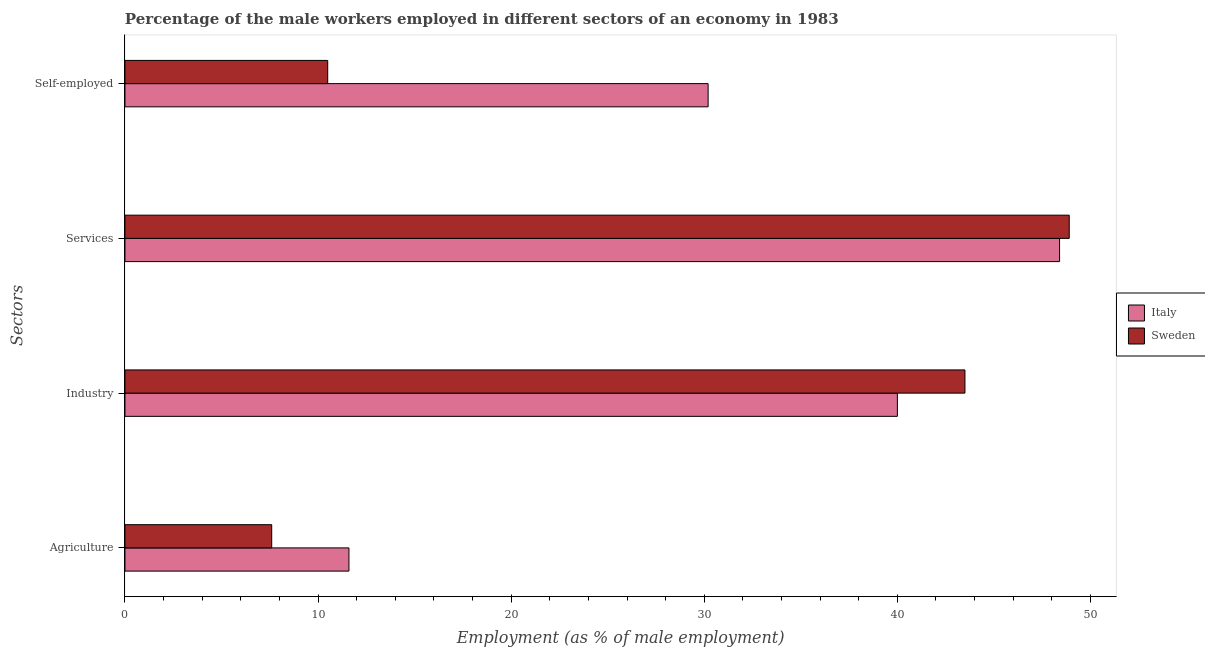How many groups of bars are there?
Offer a very short reply. 4. What is the label of the 3rd group of bars from the top?
Provide a succinct answer. Industry. What is the percentage of self employed male workers in Italy?
Offer a very short reply. 30.2. Across all countries, what is the maximum percentage of male workers in agriculture?
Keep it short and to the point. 11.6. What is the total percentage of male workers in industry in the graph?
Ensure brevity in your answer.  83.5. What is the difference between the percentage of self employed male workers in Italy and that in Sweden?
Ensure brevity in your answer.  19.7. What is the difference between the percentage of male workers in services in Sweden and the percentage of self employed male workers in Italy?
Offer a terse response. 18.7. What is the average percentage of male workers in services per country?
Give a very brief answer. 48.65. What is the difference between the percentage of male workers in agriculture and percentage of male workers in services in Sweden?
Provide a short and direct response. -41.3. What is the ratio of the percentage of male workers in industry in Sweden to that in Italy?
Keep it short and to the point. 1.09. Is the percentage of male workers in agriculture in Italy less than that in Sweden?
Provide a short and direct response. No. Is the difference between the percentage of male workers in industry in Sweden and Italy greater than the difference between the percentage of male workers in agriculture in Sweden and Italy?
Provide a short and direct response. Yes. What is the difference between the highest and the second highest percentage of self employed male workers?
Provide a short and direct response. 19.7. What is the difference between the highest and the lowest percentage of male workers in services?
Make the answer very short. 0.5. Is the sum of the percentage of male workers in agriculture in Italy and Sweden greater than the maximum percentage of self employed male workers across all countries?
Your answer should be very brief. No. Is it the case that in every country, the sum of the percentage of male workers in services and percentage of male workers in agriculture is greater than the sum of percentage of self employed male workers and percentage of male workers in industry?
Your answer should be very brief. Yes. What is the difference between two consecutive major ticks on the X-axis?
Your answer should be compact. 10. Does the graph contain any zero values?
Your answer should be very brief. No. Does the graph contain grids?
Make the answer very short. No. How many legend labels are there?
Make the answer very short. 2. What is the title of the graph?
Offer a terse response. Percentage of the male workers employed in different sectors of an economy in 1983. Does "Mauritius" appear as one of the legend labels in the graph?
Your answer should be very brief. No. What is the label or title of the X-axis?
Provide a succinct answer. Employment (as % of male employment). What is the label or title of the Y-axis?
Make the answer very short. Sectors. What is the Employment (as % of male employment) of Italy in Agriculture?
Your answer should be very brief. 11.6. What is the Employment (as % of male employment) in Sweden in Agriculture?
Your response must be concise. 7.6. What is the Employment (as % of male employment) in Italy in Industry?
Ensure brevity in your answer.  40. What is the Employment (as % of male employment) in Sweden in Industry?
Offer a very short reply. 43.5. What is the Employment (as % of male employment) of Italy in Services?
Give a very brief answer. 48.4. What is the Employment (as % of male employment) in Sweden in Services?
Your answer should be compact. 48.9. What is the Employment (as % of male employment) of Italy in Self-employed?
Keep it short and to the point. 30.2. What is the Employment (as % of male employment) in Sweden in Self-employed?
Your answer should be compact. 10.5. Across all Sectors, what is the maximum Employment (as % of male employment) in Italy?
Your answer should be compact. 48.4. Across all Sectors, what is the maximum Employment (as % of male employment) of Sweden?
Provide a short and direct response. 48.9. Across all Sectors, what is the minimum Employment (as % of male employment) in Italy?
Your answer should be very brief. 11.6. Across all Sectors, what is the minimum Employment (as % of male employment) in Sweden?
Your answer should be compact. 7.6. What is the total Employment (as % of male employment) in Italy in the graph?
Ensure brevity in your answer.  130.2. What is the total Employment (as % of male employment) of Sweden in the graph?
Provide a succinct answer. 110.5. What is the difference between the Employment (as % of male employment) of Italy in Agriculture and that in Industry?
Your response must be concise. -28.4. What is the difference between the Employment (as % of male employment) of Sweden in Agriculture and that in Industry?
Offer a terse response. -35.9. What is the difference between the Employment (as % of male employment) of Italy in Agriculture and that in Services?
Offer a very short reply. -36.8. What is the difference between the Employment (as % of male employment) of Sweden in Agriculture and that in Services?
Provide a short and direct response. -41.3. What is the difference between the Employment (as % of male employment) in Italy in Agriculture and that in Self-employed?
Provide a succinct answer. -18.6. What is the difference between the Employment (as % of male employment) of Sweden in Agriculture and that in Self-employed?
Your response must be concise. -2.9. What is the difference between the Employment (as % of male employment) of Italy in Industry and that in Services?
Your response must be concise. -8.4. What is the difference between the Employment (as % of male employment) in Sweden in Industry and that in Services?
Offer a very short reply. -5.4. What is the difference between the Employment (as % of male employment) of Italy in Industry and that in Self-employed?
Provide a short and direct response. 9.8. What is the difference between the Employment (as % of male employment) in Italy in Services and that in Self-employed?
Ensure brevity in your answer.  18.2. What is the difference between the Employment (as % of male employment) in Sweden in Services and that in Self-employed?
Give a very brief answer. 38.4. What is the difference between the Employment (as % of male employment) of Italy in Agriculture and the Employment (as % of male employment) of Sweden in Industry?
Ensure brevity in your answer.  -31.9. What is the difference between the Employment (as % of male employment) of Italy in Agriculture and the Employment (as % of male employment) of Sweden in Services?
Provide a succinct answer. -37.3. What is the difference between the Employment (as % of male employment) in Italy in Agriculture and the Employment (as % of male employment) in Sweden in Self-employed?
Offer a terse response. 1.1. What is the difference between the Employment (as % of male employment) of Italy in Industry and the Employment (as % of male employment) of Sweden in Services?
Provide a succinct answer. -8.9. What is the difference between the Employment (as % of male employment) of Italy in Industry and the Employment (as % of male employment) of Sweden in Self-employed?
Keep it short and to the point. 29.5. What is the difference between the Employment (as % of male employment) in Italy in Services and the Employment (as % of male employment) in Sweden in Self-employed?
Offer a very short reply. 37.9. What is the average Employment (as % of male employment) in Italy per Sectors?
Provide a short and direct response. 32.55. What is the average Employment (as % of male employment) in Sweden per Sectors?
Your answer should be very brief. 27.62. What is the ratio of the Employment (as % of male employment) of Italy in Agriculture to that in Industry?
Offer a terse response. 0.29. What is the ratio of the Employment (as % of male employment) in Sweden in Agriculture to that in Industry?
Provide a succinct answer. 0.17. What is the ratio of the Employment (as % of male employment) in Italy in Agriculture to that in Services?
Your answer should be very brief. 0.24. What is the ratio of the Employment (as % of male employment) of Sweden in Agriculture to that in Services?
Give a very brief answer. 0.16. What is the ratio of the Employment (as % of male employment) in Italy in Agriculture to that in Self-employed?
Give a very brief answer. 0.38. What is the ratio of the Employment (as % of male employment) in Sweden in Agriculture to that in Self-employed?
Your response must be concise. 0.72. What is the ratio of the Employment (as % of male employment) of Italy in Industry to that in Services?
Your response must be concise. 0.83. What is the ratio of the Employment (as % of male employment) in Sweden in Industry to that in Services?
Keep it short and to the point. 0.89. What is the ratio of the Employment (as % of male employment) of Italy in Industry to that in Self-employed?
Keep it short and to the point. 1.32. What is the ratio of the Employment (as % of male employment) in Sweden in Industry to that in Self-employed?
Ensure brevity in your answer.  4.14. What is the ratio of the Employment (as % of male employment) in Italy in Services to that in Self-employed?
Keep it short and to the point. 1.6. What is the ratio of the Employment (as % of male employment) of Sweden in Services to that in Self-employed?
Ensure brevity in your answer.  4.66. What is the difference between the highest and the lowest Employment (as % of male employment) of Italy?
Keep it short and to the point. 36.8. What is the difference between the highest and the lowest Employment (as % of male employment) in Sweden?
Provide a succinct answer. 41.3. 